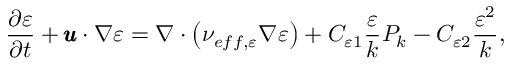<formula> <loc_0><loc_0><loc_500><loc_500>\frac { \partial \varepsilon } { \partial t } + \pm b { u } \cdot \nabla \varepsilon = \nabla \cdot \left ( \nu _ { e f f , \varepsilon } \nabla \varepsilon \right ) + C _ { \varepsilon 1 } \frac { \varepsilon } { k } P _ { k } - C _ { \varepsilon 2 } \frac { \varepsilon ^ { 2 } } { k } ,</formula> 